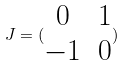Convert formula to latex. <formula><loc_0><loc_0><loc_500><loc_500>J = ( \begin{matrix} 0 & 1 \\ - 1 & 0 \end{matrix} )</formula> 